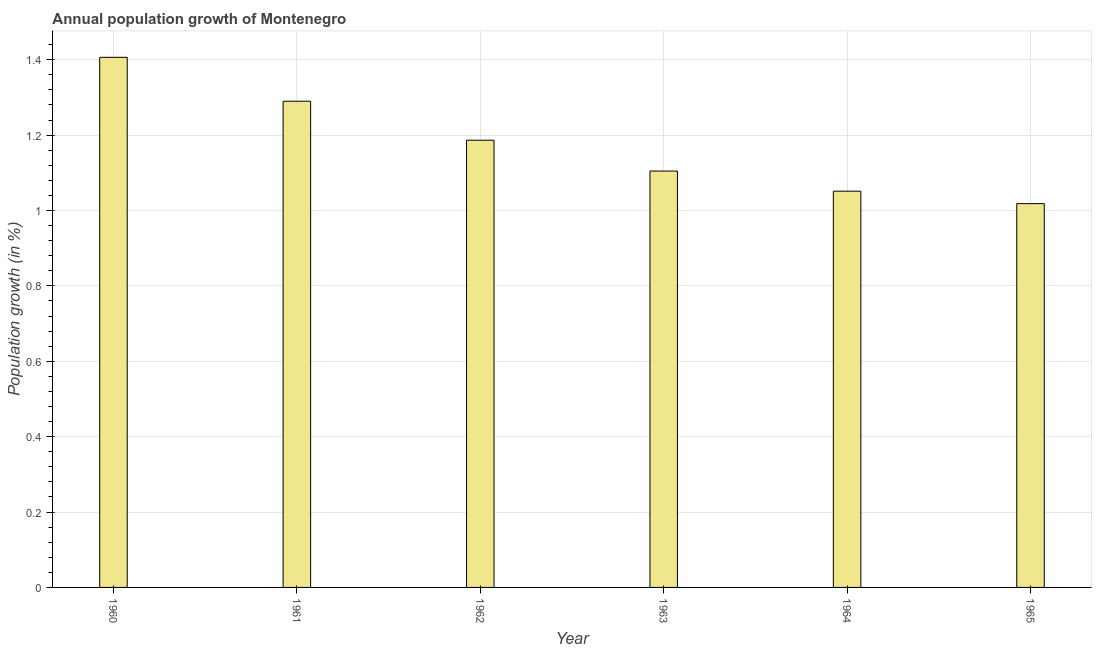Does the graph contain any zero values?
Provide a short and direct response. No. What is the title of the graph?
Offer a terse response. Annual population growth of Montenegro. What is the label or title of the X-axis?
Your answer should be very brief. Year. What is the label or title of the Y-axis?
Offer a very short reply. Population growth (in %). What is the population growth in 1960?
Offer a terse response. 1.41. Across all years, what is the maximum population growth?
Keep it short and to the point. 1.41. Across all years, what is the minimum population growth?
Keep it short and to the point. 1.02. In which year was the population growth maximum?
Ensure brevity in your answer.  1960. In which year was the population growth minimum?
Make the answer very short. 1965. What is the sum of the population growth?
Your answer should be very brief. 7.06. What is the difference between the population growth in 1962 and 1964?
Ensure brevity in your answer.  0.14. What is the average population growth per year?
Your answer should be compact. 1.18. What is the median population growth?
Offer a terse response. 1.15. What is the ratio of the population growth in 1961 to that in 1965?
Your response must be concise. 1.27. What is the difference between the highest and the second highest population growth?
Your answer should be very brief. 0.12. What is the difference between the highest and the lowest population growth?
Provide a short and direct response. 0.39. In how many years, is the population growth greater than the average population growth taken over all years?
Offer a very short reply. 3. Are the values on the major ticks of Y-axis written in scientific E-notation?
Provide a short and direct response. No. What is the Population growth (in %) in 1960?
Your response must be concise. 1.41. What is the Population growth (in %) of 1961?
Provide a succinct answer. 1.29. What is the Population growth (in %) in 1962?
Your answer should be compact. 1.19. What is the Population growth (in %) of 1963?
Your answer should be very brief. 1.1. What is the Population growth (in %) in 1964?
Provide a succinct answer. 1.05. What is the Population growth (in %) of 1965?
Provide a succinct answer. 1.02. What is the difference between the Population growth (in %) in 1960 and 1961?
Provide a succinct answer. 0.12. What is the difference between the Population growth (in %) in 1960 and 1962?
Your answer should be compact. 0.22. What is the difference between the Population growth (in %) in 1960 and 1963?
Offer a terse response. 0.3. What is the difference between the Population growth (in %) in 1960 and 1964?
Your answer should be very brief. 0.36. What is the difference between the Population growth (in %) in 1960 and 1965?
Ensure brevity in your answer.  0.39. What is the difference between the Population growth (in %) in 1961 and 1962?
Your answer should be very brief. 0.1. What is the difference between the Population growth (in %) in 1961 and 1963?
Your answer should be very brief. 0.19. What is the difference between the Population growth (in %) in 1961 and 1964?
Give a very brief answer. 0.24. What is the difference between the Population growth (in %) in 1961 and 1965?
Keep it short and to the point. 0.27. What is the difference between the Population growth (in %) in 1962 and 1963?
Provide a succinct answer. 0.08. What is the difference between the Population growth (in %) in 1962 and 1964?
Your answer should be very brief. 0.14. What is the difference between the Population growth (in %) in 1962 and 1965?
Give a very brief answer. 0.17. What is the difference between the Population growth (in %) in 1963 and 1964?
Your answer should be very brief. 0.05. What is the difference between the Population growth (in %) in 1963 and 1965?
Make the answer very short. 0.09. What is the difference between the Population growth (in %) in 1964 and 1965?
Ensure brevity in your answer.  0.03. What is the ratio of the Population growth (in %) in 1960 to that in 1961?
Your response must be concise. 1.09. What is the ratio of the Population growth (in %) in 1960 to that in 1962?
Ensure brevity in your answer.  1.19. What is the ratio of the Population growth (in %) in 1960 to that in 1963?
Ensure brevity in your answer.  1.27. What is the ratio of the Population growth (in %) in 1960 to that in 1964?
Provide a succinct answer. 1.34. What is the ratio of the Population growth (in %) in 1960 to that in 1965?
Offer a terse response. 1.38. What is the ratio of the Population growth (in %) in 1961 to that in 1962?
Your answer should be very brief. 1.09. What is the ratio of the Population growth (in %) in 1961 to that in 1963?
Your answer should be very brief. 1.17. What is the ratio of the Population growth (in %) in 1961 to that in 1964?
Provide a succinct answer. 1.23. What is the ratio of the Population growth (in %) in 1961 to that in 1965?
Make the answer very short. 1.27. What is the ratio of the Population growth (in %) in 1962 to that in 1963?
Give a very brief answer. 1.07. What is the ratio of the Population growth (in %) in 1962 to that in 1964?
Ensure brevity in your answer.  1.13. What is the ratio of the Population growth (in %) in 1962 to that in 1965?
Keep it short and to the point. 1.17. What is the ratio of the Population growth (in %) in 1963 to that in 1964?
Provide a short and direct response. 1.05. What is the ratio of the Population growth (in %) in 1963 to that in 1965?
Keep it short and to the point. 1.08. What is the ratio of the Population growth (in %) in 1964 to that in 1965?
Keep it short and to the point. 1.03. 